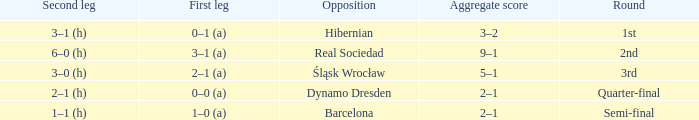What was the first leg of the semi-final? 1–0 (a). 